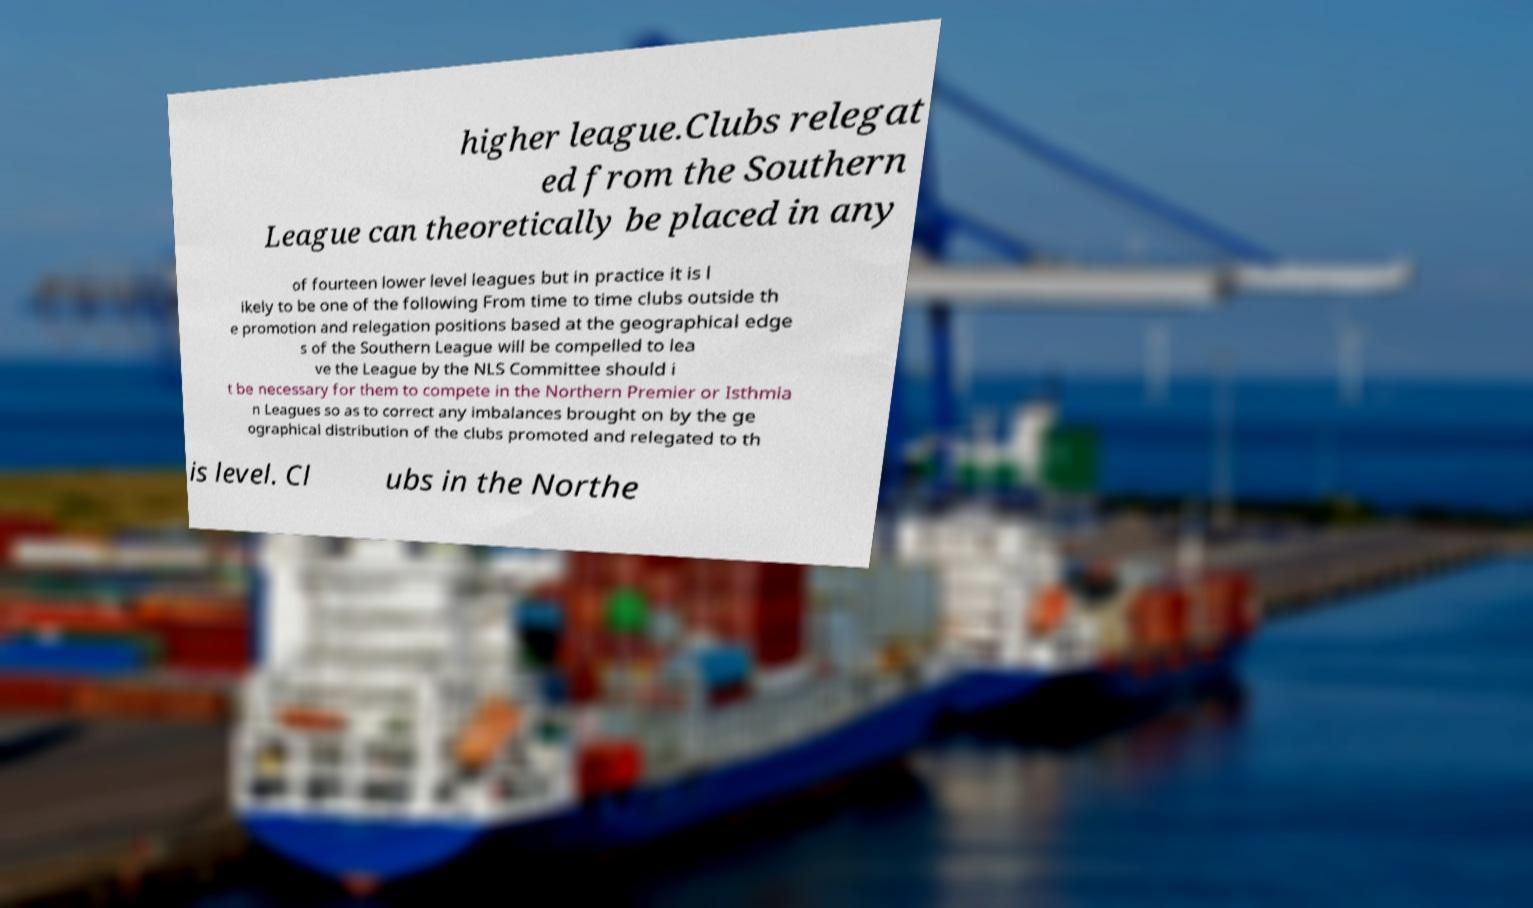Can you read and provide the text displayed in the image?This photo seems to have some interesting text. Can you extract and type it out for me? higher league.Clubs relegat ed from the Southern League can theoretically be placed in any of fourteen lower level leagues but in practice it is l ikely to be one of the following From time to time clubs outside th e promotion and relegation positions based at the geographical edge s of the Southern League will be compelled to lea ve the League by the NLS Committee should i t be necessary for them to compete in the Northern Premier or Isthmia n Leagues so as to correct any imbalances brought on by the ge ographical distribution of the clubs promoted and relegated to th is level. Cl ubs in the Northe 